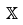<formula> <loc_0><loc_0><loc_500><loc_500>\mathbb { X }</formula> 